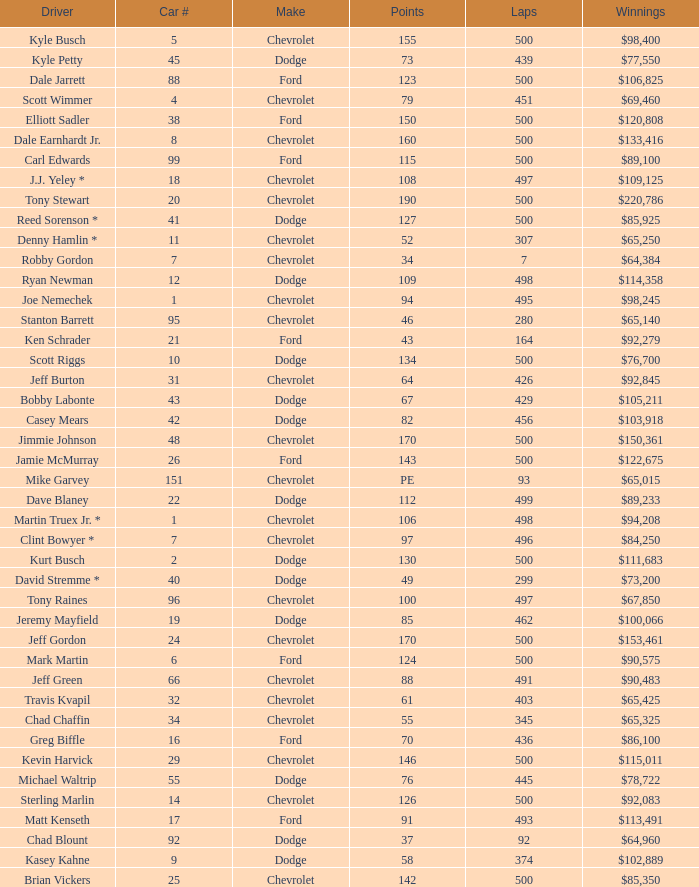What is the average car number of all the drivers who have won $111,683? 2.0. 